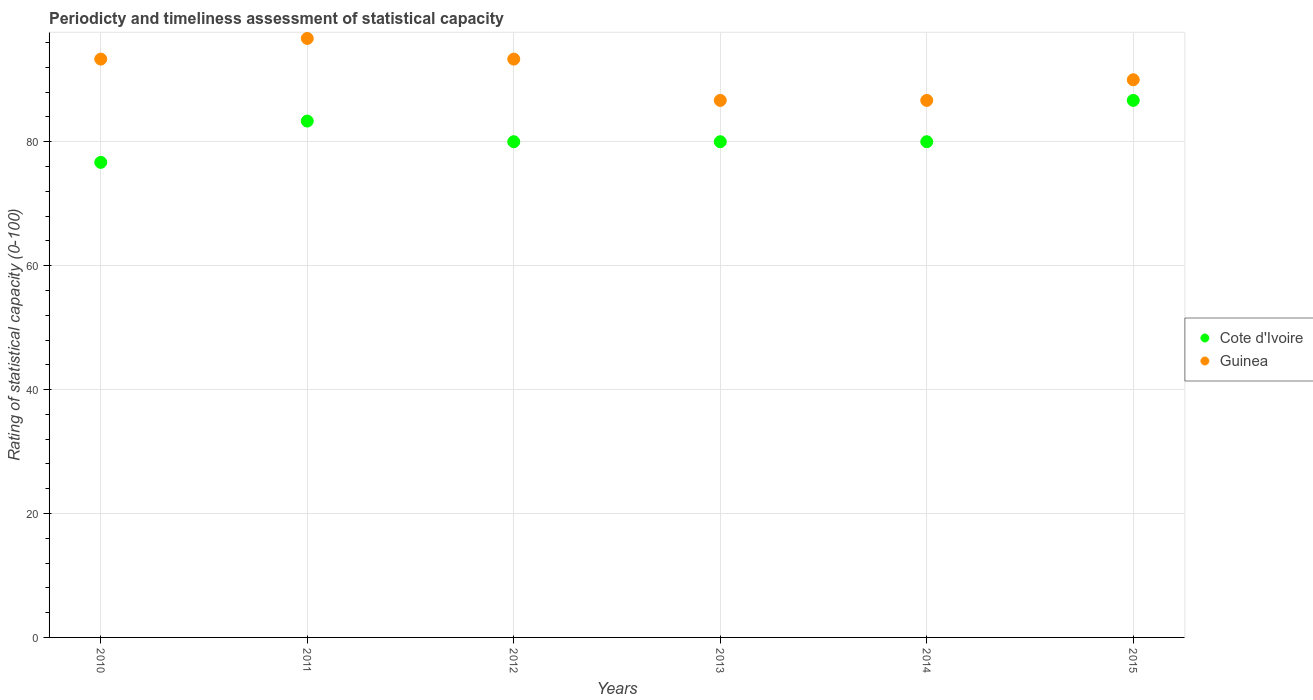How many different coloured dotlines are there?
Offer a very short reply. 2. Is the number of dotlines equal to the number of legend labels?
Give a very brief answer. Yes. Across all years, what is the maximum rating of statistical capacity in Cote d'Ivoire?
Offer a terse response. 86.67. Across all years, what is the minimum rating of statistical capacity in Cote d'Ivoire?
Your answer should be compact. 76.67. What is the total rating of statistical capacity in Guinea in the graph?
Provide a short and direct response. 546.67. What is the difference between the rating of statistical capacity in Cote d'Ivoire in 2013 and that in 2015?
Provide a short and direct response. -6.67. What is the average rating of statistical capacity in Cote d'Ivoire per year?
Your answer should be very brief. 81.11. In the year 2015, what is the difference between the rating of statistical capacity in Cote d'Ivoire and rating of statistical capacity in Guinea?
Your answer should be compact. -3.33. What is the ratio of the rating of statistical capacity in Guinea in 2014 to that in 2015?
Offer a terse response. 0.96. Is the difference between the rating of statistical capacity in Cote d'Ivoire in 2012 and 2014 greater than the difference between the rating of statistical capacity in Guinea in 2012 and 2014?
Offer a terse response. No. What is the difference between the highest and the second highest rating of statistical capacity in Guinea?
Keep it short and to the point. 3.33. What is the difference between the highest and the lowest rating of statistical capacity in Guinea?
Your answer should be compact. 10. Does the rating of statistical capacity in Guinea monotonically increase over the years?
Offer a terse response. No. Is the rating of statistical capacity in Cote d'Ivoire strictly less than the rating of statistical capacity in Guinea over the years?
Keep it short and to the point. Yes. How many years are there in the graph?
Make the answer very short. 6. Are the values on the major ticks of Y-axis written in scientific E-notation?
Provide a succinct answer. No. Does the graph contain grids?
Ensure brevity in your answer.  Yes. How many legend labels are there?
Give a very brief answer. 2. What is the title of the graph?
Provide a short and direct response. Periodicty and timeliness assessment of statistical capacity. Does "Jordan" appear as one of the legend labels in the graph?
Make the answer very short. No. What is the label or title of the Y-axis?
Offer a very short reply. Rating of statistical capacity (0-100). What is the Rating of statistical capacity (0-100) of Cote d'Ivoire in 2010?
Give a very brief answer. 76.67. What is the Rating of statistical capacity (0-100) of Guinea in 2010?
Provide a succinct answer. 93.33. What is the Rating of statistical capacity (0-100) in Cote d'Ivoire in 2011?
Your answer should be compact. 83.33. What is the Rating of statistical capacity (0-100) of Guinea in 2011?
Your answer should be compact. 96.67. What is the Rating of statistical capacity (0-100) of Guinea in 2012?
Your answer should be compact. 93.33. What is the Rating of statistical capacity (0-100) of Guinea in 2013?
Your answer should be very brief. 86.67. What is the Rating of statistical capacity (0-100) of Cote d'Ivoire in 2014?
Offer a very short reply. 80. What is the Rating of statistical capacity (0-100) of Guinea in 2014?
Offer a terse response. 86.67. What is the Rating of statistical capacity (0-100) of Cote d'Ivoire in 2015?
Give a very brief answer. 86.67. Across all years, what is the maximum Rating of statistical capacity (0-100) of Cote d'Ivoire?
Provide a succinct answer. 86.67. Across all years, what is the maximum Rating of statistical capacity (0-100) of Guinea?
Your answer should be compact. 96.67. Across all years, what is the minimum Rating of statistical capacity (0-100) of Cote d'Ivoire?
Your answer should be compact. 76.67. Across all years, what is the minimum Rating of statistical capacity (0-100) of Guinea?
Offer a very short reply. 86.67. What is the total Rating of statistical capacity (0-100) in Cote d'Ivoire in the graph?
Make the answer very short. 486.67. What is the total Rating of statistical capacity (0-100) of Guinea in the graph?
Offer a very short reply. 546.67. What is the difference between the Rating of statistical capacity (0-100) of Cote d'Ivoire in 2010 and that in 2011?
Provide a succinct answer. -6.67. What is the difference between the Rating of statistical capacity (0-100) of Guinea in 2010 and that in 2011?
Ensure brevity in your answer.  -3.33. What is the difference between the Rating of statistical capacity (0-100) of Cote d'Ivoire in 2010 and that in 2012?
Your answer should be very brief. -3.33. What is the difference between the Rating of statistical capacity (0-100) of Cote d'Ivoire in 2010 and that in 2013?
Provide a succinct answer. -3.33. What is the difference between the Rating of statistical capacity (0-100) in Guinea in 2010 and that in 2014?
Keep it short and to the point. 6.67. What is the difference between the Rating of statistical capacity (0-100) of Cote d'Ivoire in 2011 and that in 2012?
Make the answer very short. 3.33. What is the difference between the Rating of statistical capacity (0-100) of Guinea in 2011 and that in 2012?
Your answer should be compact. 3.33. What is the difference between the Rating of statistical capacity (0-100) in Guinea in 2011 and that in 2013?
Give a very brief answer. 10. What is the difference between the Rating of statistical capacity (0-100) of Cote d'Ivoire in 2011 and that in 2014?
Provide a succinct answer. 3.33. What is the difference between the Rating of statistical capacity (0-100) of Cote d'Ivoire in 2011 and that in 2015?
Give a very brief answer. -3.33. What is the difference between the Rating of statistical capacity (0-100) in Guinea in 2012 and that in 2013?
Keep it short and to the point. 6.67. What is the difference between the Rating of statistical capacity (0-100) in Cote d'Ivoire in 2012 and that in 2015?
Offer a terse response. -6.67. What is the difference between the Rating of statistical capacity (0-100) of Guinea in 2012 and that in 2015?
Your response must be concise. 3.33. What is the difference between the Rating of statistical capacity (0-100) in Cote d'Ivoire in 2013 and that in 2014?
Provide a short and direct response. 0. What is the difference between the Rating of statistical capacity (0-100) in Guinea in 2013 and that in 2014?
Offer a very short reply. 0. What is the difference between the Rating of statistical capacity (0-100) in Cote d'Ivoire in 2013 and that in 2015?
Provide a short and direct response. -6.67. What is the difference between the Rating of statistical capacity (0-100) of Guinea in 2013 and that in 2015?
Provide a succinct answer. -3.33. What is the difference between the Rating of statistical capacity (0-100) of Cote d'Ivoire in 2014 and that in 2015?
Offer a very short reply. -6.67. What is the difference between the Rating of statistical capacity (0-100) in Guinea in 2014 and that in 2015?
Offer a terse response. -3.33. What is the difference between the Rating of statistical capacity (0-100) in Cote d'Ivoire in 2010 and the Rating of statistical capacity (0-100) in Guinea in 2011?
Ensure brevity in your answer.  -20. What is the difference between the Rating of statistical capacity (0-100) in Cote d'Ivoire in 2010 and the Rating of statistical capacity (0-100) in Guinea in 2012?
Your answer should be very brief. -16.67. What is the difference between the Rating of statistical capacity (0-100) in Cote d'Ivoire in 2010 and the Rating of statistical capacity (0-100) in Guinea in 2015?
Your answer should be very brief. -13.33. What is the difference between the Rating of statistical capacity (0-100) in Cote d'Ivoire in 2011 and the Rating of statistical capacity (0-100) in Guinea in 2012?
Offer a terse response. -10. What is the difference between the Rating of statistical capacity (0-100) of Cote d'Ivoire in 2011 and the Rating of statistical capacity (0-100) of Guinea in 2015?
Offer a very short reply. -6.67. What is the difference between the Rating of statistical capacity (0-100) in Cote d'Ivoire in 2012 and the Rating of statistical capacity (0-100) in Guinea in 2013?
Ensure brevity in your answer.  -6.67. What is the difference between the Rating of statistical capacity (0-100) in Cote d'Ivoire in 2012 and the Rating of statistical capacity (0-100) in Guinea in 2014?
Give a very brief answer. -6.67. What is the difference between the Rating of statistical capacity (0-100) of Cote d'Ivoire in 2012 and the Rating of statistical capacity (0-100) of Guinea in 2015?
Offer a terse response. -10. What is the difference between the Rating of statistical capacity (0-100) in Cote d'Ivoire in 2013 and the Rating of statistical capacity (0-100) in Guinea in 2014?
Offer a very short reply. -6.67. What is the difference between the Rating of statistical capacity (0-100) of Cote d'Ivoire in 2014 and the Rating of statistical capacity (0-100) of Guinea in 2015?
Make the answer very short. -10. What is the average Rating of statistical capacity (0-100) in Cote d'Ivoire per year?
Keep it short and to the point. 81.11. What is the average Rating of statistical capacity (0-100) in Guinea per year?
Your answer should be very brief. 91.11. In the year 2010, what is the difference between the Rating of statistical capacity (0-100) in Cote d'Ivoire and Rating of statistical capacity (0-100) in Guinea?
Keep it short and to the point. -16.67. In the year 2011, what is the difference between the Rating of statistical capacity (0-100) in Cote d'Ivoire and Rating of statistical capacity (0-100) in Guinea?
Provide a succinct answer. -13.33. In the year 2012, what is the difference between the Rating of statistical capacity (0-100) in Cote d'Ivoire and Rating of statistical capacity (0-100) in Guinea?
Your answer should be compact. -13.33. In the year 2013, what is the difference between the Rating of statistical capacity (0-100) in Cote d'Ivoire and Rating of statistical capacity (0-100) in Guinea?
Your response must be concise. -6.67. In the year 2014, what is the difference between the Rating of statistical capacity (0-100) of Cote d'Ivoire and Rating of statistical capacity (0-100) of Guinea?
Your answer should be compact. -6.67. In the year 2015, what is the difference between the Rating of statistical capacity (0-100) in Cote d'Ivoire and Rating of statistical capacity (0-100) in Guinea?
Offer a terse response. -3.33. What is the ratio of the Rating of statistical capacity (0-100) of Cote d'Ivoire in 2010 to that in 2011?
Your response must be concise. 0.92. What is the ratio of the Rating of statistical capacity (0-100) in Guinea in 2010 to that in 2011?
Provide a short and direct response. 0.97. What is the ratio of the Rating of statistical capacity (0-100) in Cote d'Ivoire in 2010 to that in 2012?
Offer a terse response. 0.96. What is the ratio of the Rating of statistical capacity (0-100) in Guinea in 2010 to that in 2012?
Offer a very short reply. 1. What is the ratio of the Rating of statistical capacity (0-100) of Cote d'Ivoire in 2010 to that in 2013?
Provide a short and direct response. 0.96. What is the ratio of the Rating of statistical capacity (0-100) of Cote d'Ivoire in 2010 to that in 2014?
Make the answer very short. 0.96. What is the ratio of the Rating of statistical capacity (0-100) in Cote d'Ivoire in 2010 to that in 2015?
Provide a short and direct response. 0.88. What is the ratio of the Rating of statistical capacity (0-100) in Guinea in 2010 to that in 2015?
Your response must be concise. 1.04. What is the ratio of the Rating of statistical capacity (0-100) in Cote d'Ivoire in 2011 to that in 2012?
Keep it short and to the point. 1.04. What is the ratio of the Rating of statistical capacity (0-100) of Guinea in 2011 to that in 2012?
Provide a succinct answer. 1.04. What is the ratio of the Rating of statistical capacity (0-100) of Cote d'Ivoire in 2011 to that in 2013?
Your answer should be compact. 1.04. What is the ratio of the Rating of statistical capacity (0-100) in Guinea in 2011 to that in 2013?
Ensure brevity in your answer.  1.12. What is the ratio of the Rating of statistical capacity (0-100) in Cote d'Ivoire in 2011 to that in 2014?
Provide a short and direct response. 1.04. What is the ratio of the Rating of statistical capacity (0-100) in Guinea in 2011 to that in 2014?
Keep it short and to the point. 1.12. What is the ratio of the Rating of statistical capacity (0-100) of Cote d'Ivoire in 2011 to that in 2015?
Your answer should be very brief. 0.96. What is the ratio of the Rating of statistical capacity (0-100) of Guinea in 2011 to that in 2015?
Ensure brevity in your answer.  1.07. What is the ratio of the Rating of statistical capacity (0-100) of Guinea in 2012 to that in 2013?
Offer a terse response. 1.08. What is the ratio of the Rating of statistical capacity (0-100) of Guinea in 2012 to that in 2014?
Your answer should be compact. 1.08. What is the ratio of the Rating of statistical capacity (0-100) of Cote d'Ivoire in 2013 to that in 2014?
Your response must be concise. 1. What is the ratio of the Rating of statistical capacity (0-100) of Cote d'Ivoire in 2013 to that in 2015?
Offer a terse response. 0.92. What is the difference between the highest and the second highest Rating of statistical capacity (0-100) in Cote d'Ivoire?
Provide a short and direct response. 3.33. What is the difference between the highest and the second highest Rating of statistical capacity (0-100) in Guinea?
Provide a succinct answer. 3.33. What is the difference between the highest and the lowest Rating of statistical capacity (0-100) in Cote d'Ivoire?
Offer a terse response. 10. 